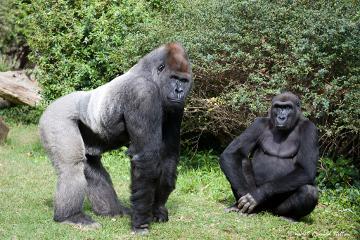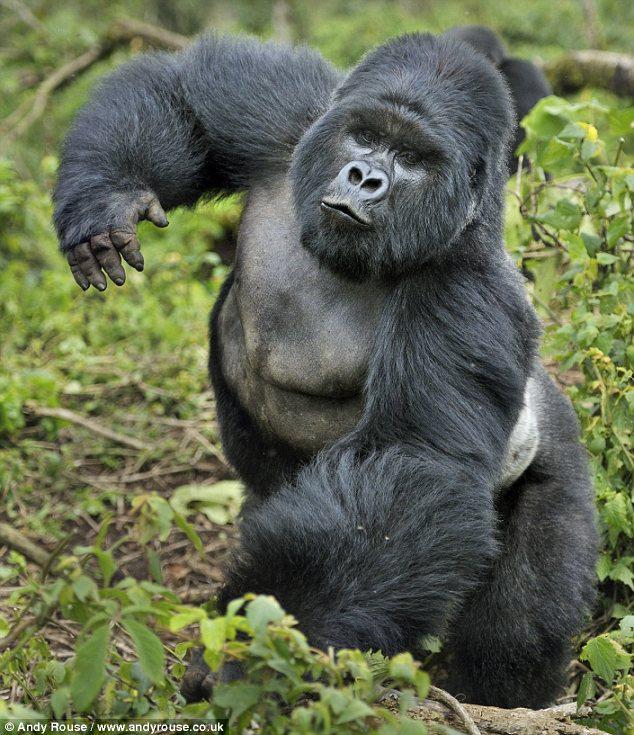The first image is the image on the left, the second image is the image on the right. Analyze the images presented: Is the assertion "There are exactly three gorillas." valid? Answer yes or no. Yes. The first image is the image on the left, the second image is the image on the right. Examine the images to the left and right. Is the description "A baby gorilla is in front of a sitting adult gorilla with both hands touching its head, in one image." accurate? Answer yes or no. No. 